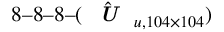Convert formula to latex. <formula><loc_0><loc_0><loc_500><loc_500>8 8 8 ( \hat { U } _ { u , 1 0 4 \times 1 0 4 } )</formula> 